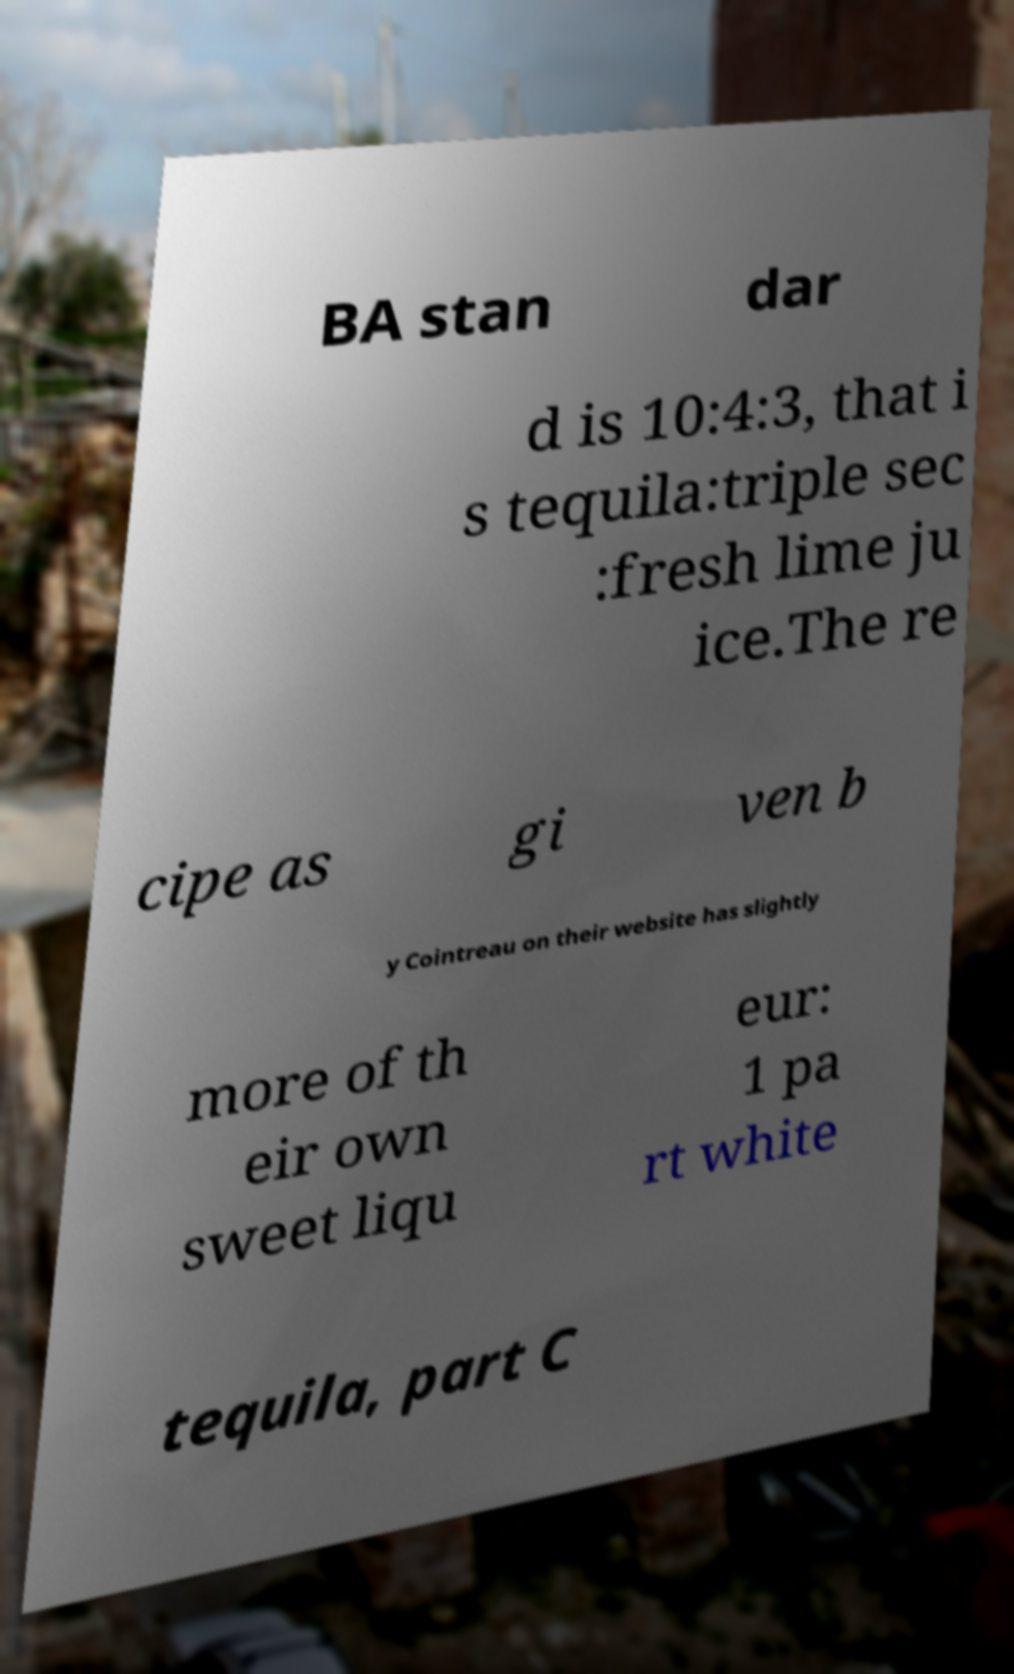Can you accurately transcribe the text from the provided image for me? BA stan dar d is 10:4:3, that i s tequila:triple sec :fresh lime ju ice.The re cipe as gi ven b y Cointreau on their website has slightly more of th eir own sweet liqu eur: 1 pa rt white tequila, part C 